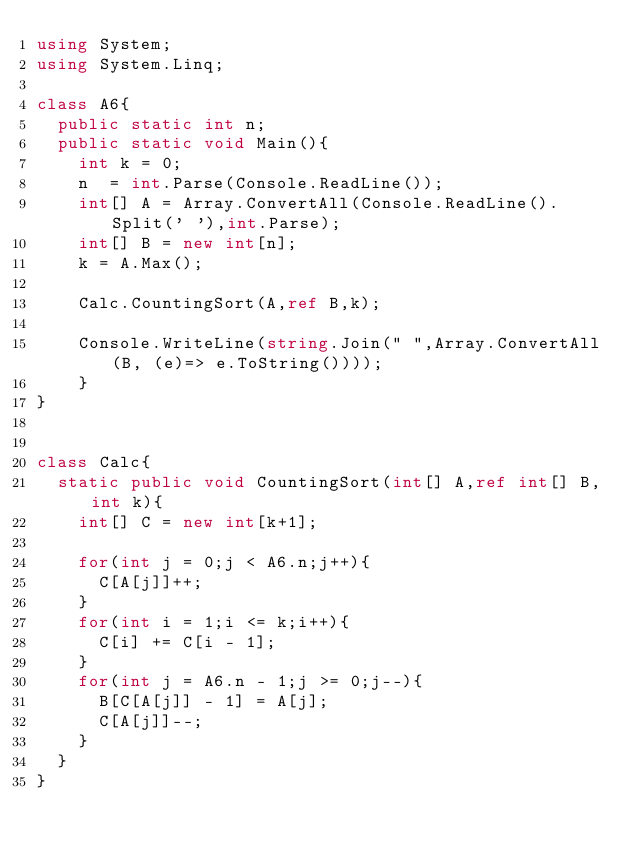<code> <loc_0><loc_0><loc_500><loc_500><_C#_>using System;
using System.Linq;

class A6{
  public static int n;
  public static void Main(){
    int k = 0;
    n  = int.Parse(Console.ReadLine());
    int[] A = Array.ConvertAll(Console.ReadLine().Split(' '),int.Parse);
    int[] B = new int[n];
    k = A.Max();

    Calc.CountingSort(A,ref B,k);

    Console.WriteLine(string.Join(" ",Array.ConvertAll(B, (e)=> e.ToString())));
    }
}


class Calc{
  static public void CountingSort(int[] A,ref int[] B,int k){
    int[] C = new int[k+1];

    for(int j = 0;j < A6.n;j++){
      C[A[j]]++;
    }
    for(int i = 1;i <= k;i++){
      C[i] += C[i - 1];
    }
    for(int j = A6.n - 1;j >= 0;j--){
      B[C[A[j]] - 1] = A[j];
      C[A[j]]--;
    }
  }
}
</code> 